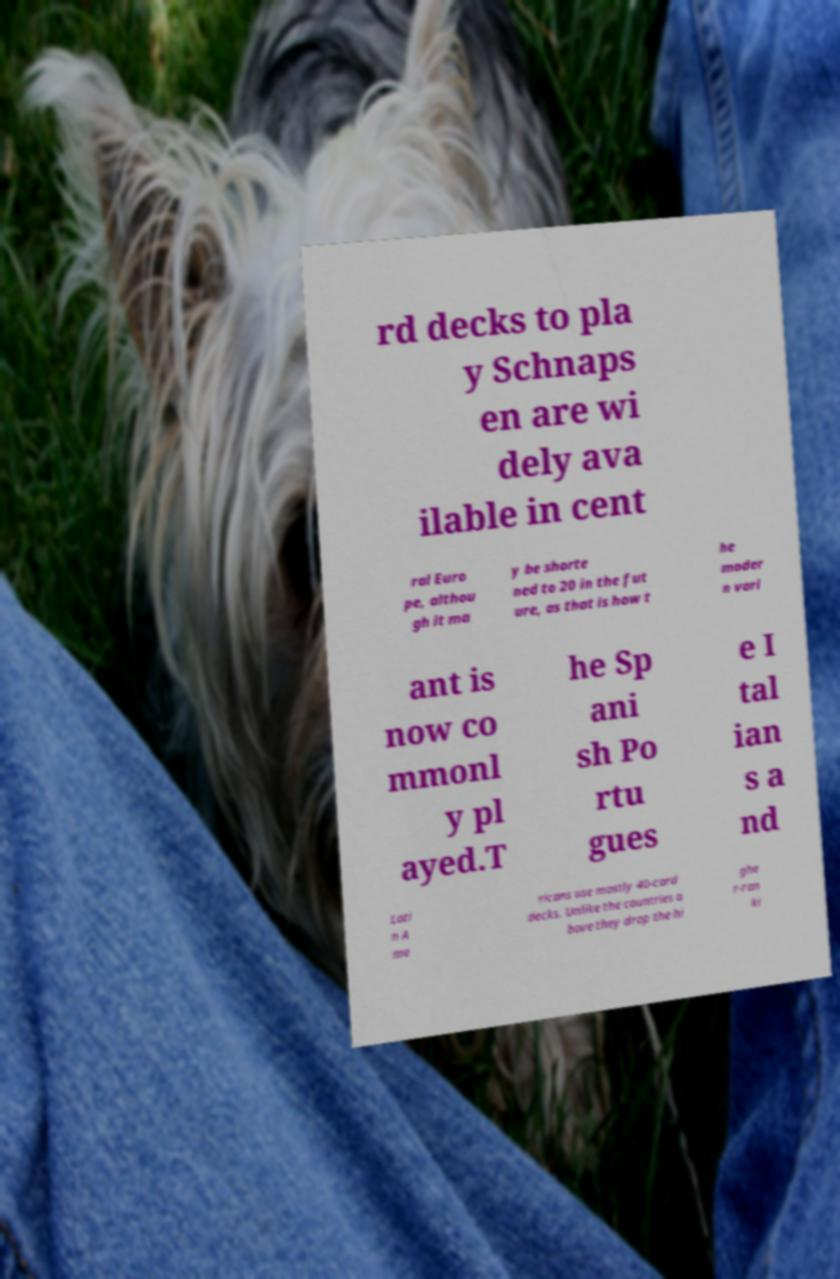What messages or text are displayed in this image? I need them in a readable, typed format. rd decks to pla y Schnaps en are wi dely ava ilable in cent ral Euro pe, althou gh it ma y be shorte ned to 20 in the fut ure, as that is how t he moder n vari ant is now co mmonl y pl ayed.T he Sp ani sh Po rtu gues e I tal ian s a nd Lati n A me ricans use mostly 40-card decks. Unlike the countries a bove they drop the hi ghe r-ran ki 